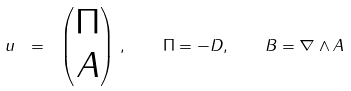<formula> <loc_0><loc_0><loc_500><loc_500>u \ = \ \begin{pmatrix} \Pi \\ A \end{pmatrix} \, , \quad \Pi = - D , \quad B = \nabla \wedge A</formula> 